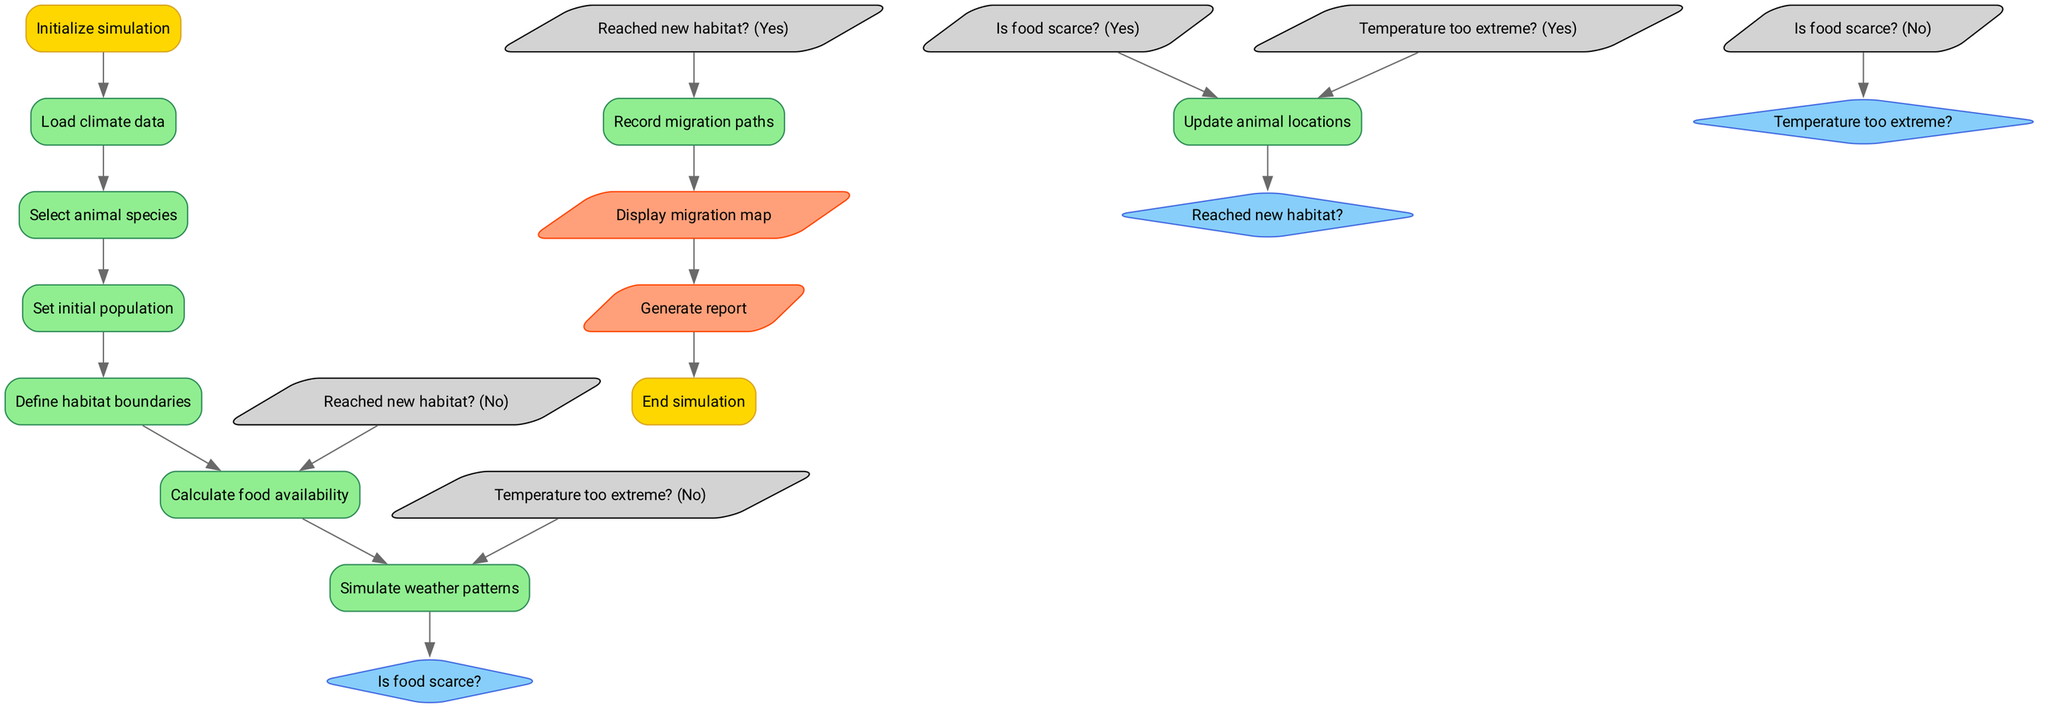What is the first step in the simulation? The first step in the simulation is "Initialize simulation," which is the starting node of the flowchart.
Answer: Initialize simulation How many decision nodes are there in the diagram? The diagram contains three decision nodes: "Is food scarce?", "Temperature too extreme?", and "Reached new habitat?".
Answer: 3 What happens if food is scarce? If food is scarce, the next step in the process is to "Update animal locations," as directed by the flowchart after this decision.
Answer: Update animal locations What is the output of the simulation? The simulation produces two outputs: "Display migration map" and "Generate report," which are the final results after processing the flowchart.
Answer: Display migration map, Generate report How many processes are there between "Select animal species" and "Calculate food availability"? There are two processes between these two nodes: "Set initial population" and "Define habitat boundaries."
Answer: 2 What does the flowchart do if the temperature is too extreme? If the temperature is too extreme, the flowchart directs to "Update animal locations," which is the next action taken based on that decision node.
Answer: Update animal locations What connects "Reached new habitat?" to the next process? If the decision node "Reached new habitat?" evaluates as Yes, it connects to "Record migration paths," and if No, it loops back to "Calculate food availability."
Answer: Record migration paths, Calculate food availability Which process follows "Simulate weather patterns"? The process that follows "Simulate weather patterns" is the decision point "Is food scarce?".
Answer: Is food scarce? What is the final action before ending the simulation? The final action before ending the simulation is "Generate report," which occurs after displaying the migration map.
Answer: Generate report 